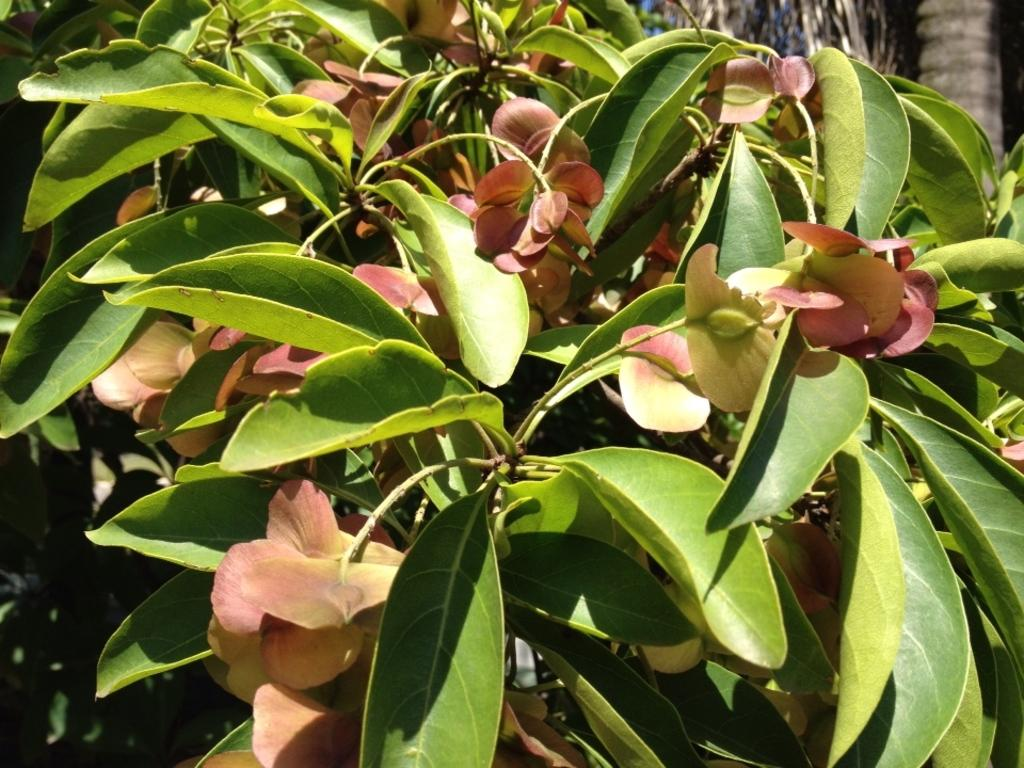What is the main subject of the image? The main subject of the image is plants. Where are the plants located in the image? The plants are in the center of the image. What colors can be seen on the plants? The plants have red and green colors. What type of tent can be seen in the background of the image? There is no tent present in the image; it features plants with red and green colors in the center. 